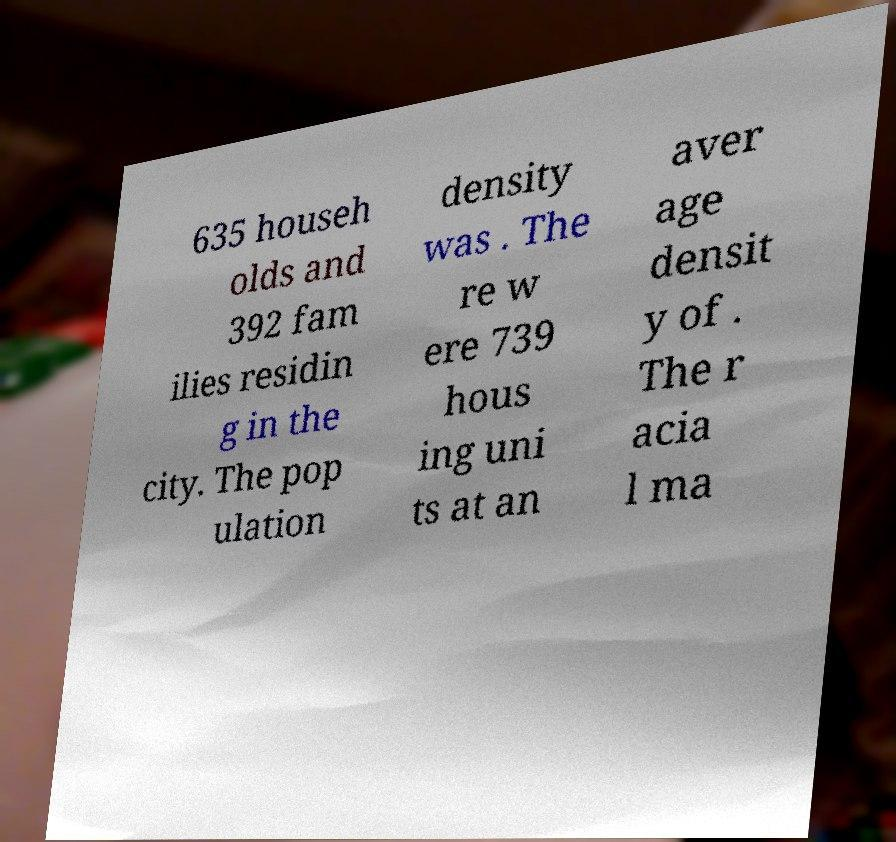There's text embedded in this image that I need extracted. Can you transcribe it verbatim? 635 househ olds and 392 fam ilies residin g in the city. The pop ulation density was . The re w ere 739 hous ing uni ts at an aver age densit y of . The r acia l ma 